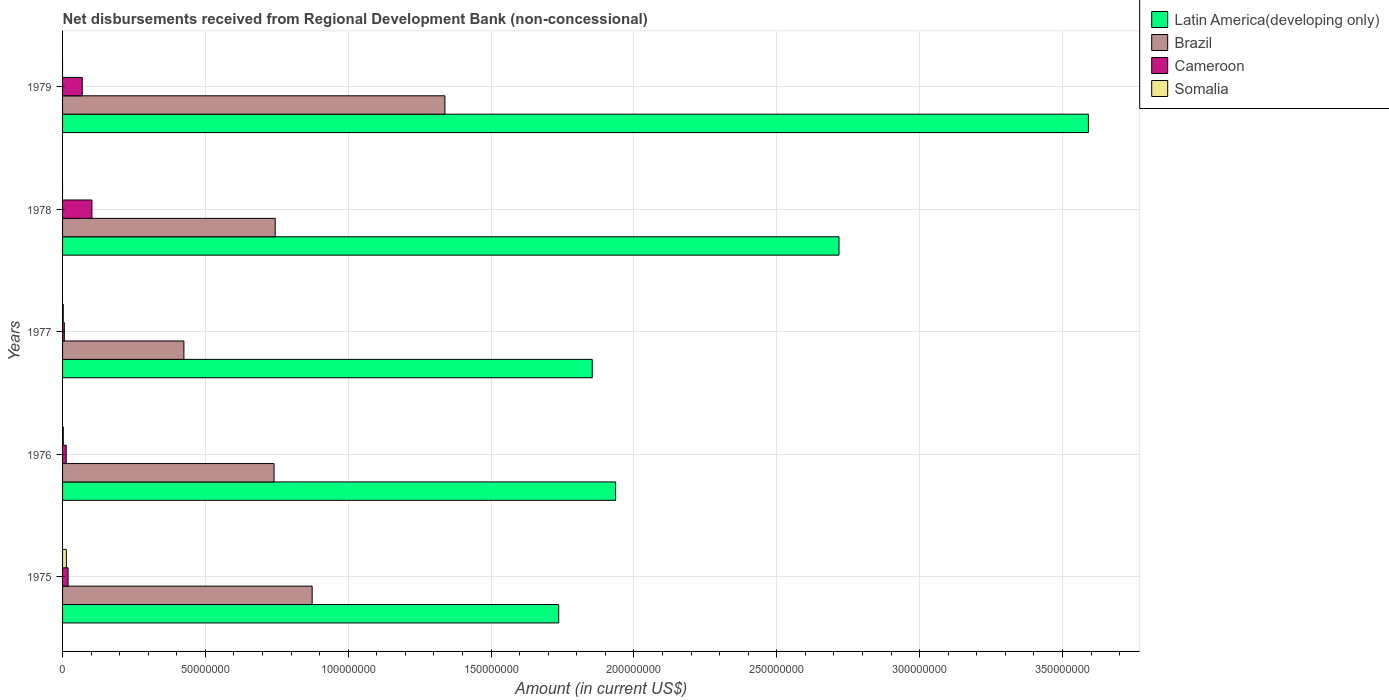Are the number of bars per tick equal to the number of legend labels?
Ensure brevity in your answer.  No. Are the number of bars on each tick of the Y-axis equal?
Your answer should be very brief. No. How many bars are there on the 2nd tick from the top?
Offer a very short reply. 3. What is the label of the 1st group of bars from the top?
Provide a short and direct response. 1979. What is the amount of disbursements received from Regional Development Bank in Brazil in 1978?
Ensure brevity in your answer.  7.44e+07. Across all years, what is the maximum amount of disbursements received from Regional Development Bank in Brazil?
Offer a very short reply. 1.34e+08. Across all years, what is the minimum amount of disbursements received from Regional Development Bank in Brazil?
Provide a short and direct response. 4.25e+07. In which year was the amount of disbursements received from Regional Development Bank in Brazil maximum?
Give a very brief answer. 1979. What is the total amount of disbursements received from Regional Development Bank in Latin America(developing only) in the graph?
Your response must be concise. 1.18e+09. What is the difference between the amount of disbursements received from Regional Development Bank in Brazil in 1975 and that in 1979?
Your response must be concise. -4.65e+07. What is the difference between the amount of disbursements received from Regional Development Bank in Brazil in 1978 and the amount of disbursements received from Regional Development Bank in Somalia in 1975?
Give a very brief answer. 7.31e+07. What is the average amount of disbursements received from Regional Development Bank in Brazil per year?
Offer a terse response. 8.24e+07. In the year 1978, what is the difference between the amount of disbursements received from Regional Development Bank in Latin America(developing only) and amount of disbursements received from Regional Development Bank in Brazil?
Your response must be concise. 1.97e+08. In how many years, is the amount of disbursements received from Regional Development Bank in Cameroon greater than 250000000 US$?
Offer a terse response. 0. What is the ratio of the amount of disbursements received from Regional Development Bank in Cameroon in 1977 to that in 1978?
Offer a terse response. 0.06. What is the difference between the highest and the second highest amount of disbursements received from Regional Development Bank in Somalia?
Give a very brief answer. 1.07e+06. What is the difference between the highest and the lowest amount of disbursements received from Regional Development Bank in Cameroon?
Keep it short and to the point. 9.65e+06. In how many years, is the amount of disbursements received from Regional Development Bank in Cameroon greater than the average amount of disbursements received from Regional Development Bank in Cameroon taken over all years?
Make the answer very short. 2. Is the sum of the amount of disbursements received from Regional Development Bank in Cameroon in 1975 and 1978 greater than the maximum amount of disbursements received from Regional Development Bank in Somalia across all years?
Provide a succinct answer. Yes. Is it the case that in every year, the sum of the amount of disbursements received from Regional Development Bank in Somalia and amount of disbursements received from Regional Development Bank in Cameroon is greater than the sum of amount of disbursements received from Regional Development Bank in Brazil and amount of disbursements received from Regional Development Bank in Latin America(developing only)?
Give a very brief answer. No. What is the difference between two consecutive major ticks on the X-axis?
Give a very brief answer. 5.00e+07. Does the graph contain grids?
Provide a short and direct response. Yes. What is the title of the graph?
Offer a terse response. Net disbursements received from Regional Development Bank (non-concessional). What is the label or title of the X-axis?
Keep it short and to the point. Amount (in current US$). What is the label or title of the Y-axis?
Your answer should be compact. Years. What is the Amount (in current US$) of Latin America(developing only) in 1975?
Keep it short and to the point. 1.74e+08. What is the Amount (in current US$) in Brazil in 1975?
Give a very brief answer. 8.74e+07. What is the Amount (in current US$) in Cameroon in 1975?
Offer a very short reply. 1.93e+06. What is the Amount (in current US$) in Somalia in 1975?
Your answer should be very brief. 1.33e+06. What is the Amount (in current US$) in Latin America(developing only) in 1976?
Provide a short and direct response. 1.94e+08. What is the Amount (in current US$) of Brazil in 1976?
Offer a terse response. 7.40e+07. What is the Amount (in current US$) in Cameroon in 1976?
Your response must be concise. 1.27e+06. What is the Amount (in current US$) in Somalia in 1976?
Offer a very short reply. 2.63e+05. What is the Amount (in current US$) of Latin America(developing only) in 1977?
Offer a very short reply. 1.85e+08. What is the Amount (in current US$) in Brazil in 1977?
Your response must be concise. 4.25e+07. What is the Amount (in current US$) of Cameroon in 1977?
Keep it short and to the point. 6.15e+05. What is the Amount (in current US$) in Somalia in 1977?
Provide a succinct answer. 2.51e+05. What is the Amount (in current US$) in Latin America(developing only) in 1978?
Your answer should be very brief. 2.72e+08. What is the Amount (in current US$) in Brazil in 1978?
Give a very brief answer. 7.44e+07. What is the Amount (in current US$) of Cameroon in 1978?
Keep it short and to the point. 1.03e+07. What is the Amount (in current US$) of Somalia in 1978?
Your response must be concise. 0. What is the Amount (in current US$) of Latin America(developing only) in 1979?
Provide a succinct answer. 3.59e+08. What is the Amount (in current US$) in Brazil in 1979?
Your answer should be compact. 1.34e+08. What is the Amount (in current US$) in Cameroon in 1979?
Make the answer very short. 6.90e+06. What is the Amount (in current US$) in Somalia in 1979?
Provide a short and direct response. 0. Across all years, what is the maximum Amount (in current US$) in Latin America(developing only)?
Give a very brief answer. 3.59e+08. Across all years, what is the maximum Amount (in current US$) in Brazil?
Provide a succinct answer. 1.34e+08. Across all years, what is the maximum Amount (in current US$) in Cameroon?
Your answer should be very brief. 1.03e+07. Across all years, what is the maximum Amount (in current US$) of Somalia?
Give a very brief answer. 1.33e+06. Across all years, what is the minimum Amount (in current US$) in Latin America(developing only)?
Your answer should be very brief. 1.74e+08. Across all years, what is the minimum Amount (in current US$) of Brazil?
Give a very brief answer. 4.25e+07. Across all years, what is the minimum Amount (in current US$) in Cameroon?
Your answer should be very brief. 6.15e+05. What is the total Amount (in current US$) in Latin America(developing only) in the graph?
Ensure brevity in your answer.  1.18e+09. What is the total Amount (in current US$) of Brazil in the graph?
Offer a terse response. 4.12e+08. What is the total Amount (in current US$) of Cameroon in the graph?
Your answer should be very brief. 2.10e+07. What is the total Amount (in current US$) of Somalia in the graph?
Offer a very short reply. 1.85e+06. What is the difference between the Amount (in current US$) of Latin America(developing only) in 1975 and that in 1976?
Offer a terse response. -1.99e+07. What is the difference between the Amount (in current US$) of Brazil in 1975 and that in 1976?
Your response must be concise. 1.33e+07. What is the difference between the Amount (in current US$) in Cameroon in 1975 and that in 1976?
Provide a short and direct response. 6.55e+05. What is the difference between the Amount (in current US$) of Somalia in 1975 and that in 1976?
Offer a very short reply. 1.07e+06. What is the difference between the Amount (in current US$) in Latin America(developing only) in 1975 and that in 1977?
Offer a terse response. -1.17e+07. What is the difference between the Amount (in current US$) of Brazil in 1975 and that in 1977?
Provide a short and direct response. 4.49e+07. What is the difference between the Amount (in current US$) in Cameroon in 1975 and that in 1977?
Provide a succinct answer. 1.31e+06. What is the difference between the Amount (in current US$) in Somalia in 1975 and that in 1977?
Offer a very short reply. 1.08e+06. What is the difference between the Amount (in current US$) in Latin America(developing only) in 1975 and that in 1978?
Your answer should be very brief. -9.81e+07. What is the difference between the Amount (in current US$) of Brazil in 1975 and that in 1978?
Your answer should be compact. 1.29e+07. What is the difference between the Amount (in current US$) of Cameroon in 1975 and that in 1978?
Provide a short and direct response. -8.34e+06. What is the difference between the Amount (in current US$) of Latin America(developing only) in 1975 and that in 1979?
Offer a terse response. -1.85e+08. What is the difference between the Amount (in current US$) of Brazil in 1975 and that in 1979?
Provide a short and direct response. -4.65e+07. What is the difference between the Amount (in current US$) in Cameroon in 1975 and that in 1979?
Offer a terse response. -4.97e+06. What is the difference between the Amount (in current US$) of Latin America(developing only) in 1976 and that in 1977?
Provide a short and direct response. 8.18e+06. What is the difference between the Amount (in current US$) of Brazil in 1976 and that in 1977?
Ensure brevity in your answer.  3.16e+07. What is the difference between the Amount (in current US$) of Cameroon in 1976 and that in 1977?
Offer a terse response. 6.56e+05. What is the difference between the Amount (in current US$) of Somalia in 1976 and that in 1977?
Make the answer very short. 1.20e+04. What is the difference between the Amount (in current US$) of Latin America(developing only) in 1976 and that in 1978?
Offer a terse response. -7.82e+07. What is the difference between the Amount (in current US$) of Brazil in 1976 and that in 1978?
Offer a terse response. -3.96e+05. What is the difference between the Amount (in current US$) in Cameroon in 1976 and that in 1978?
Your answer should be very brief. -9.00e+06. What is the difference between the Amount (in current US$) in Latin America(developing only) in 1976 and that in 1979?
Offer a very short reply. -1.65e+08. What is the difference between the Amount (in current US$) of Brazil in 1976 and that in 1979?
Offer a terse response. -5.98e+07. What is the difference between the Amount (in current US$) of Cameroon in 1976 and that in 1979?
Offer a very short reply. -5.62e+06. What is the difference between the Amount (in current US$) in Latin America(developing only) in 1977 and that in 1978?
Give a very brief answer. -8.64e+07. What is the difference between the Amount (in current US$) of Brazil in 1977 and that in 1978?
Keep it short and to the point. -3.20e+07. What is the difference between the Amount (in current US$) of Cameroon in 1977 and that in 1978?
Provide a succinct answer. -9.65e+06. What is the difference between the Amount (in current US$) of Latin America(developing only) in 1977 and that in 1979?
Keep it short and to the point. -1.74e+08. What is the difference between the Amount (in current US$) in Brazil in 1977 and that in 1979?
Make the answer very short. -9.14e+07. What is the difference between the Amount (in current US$) of Cameroon in 1977 and that in 1979?
Ensure brevity in your answer.  -6.28e+06. What is the difference between the Amount (in current US$) in Latin America(developing only) in 1978 and that in 1979?
Provide a succinct answer. -8.73e+07. What is the difference between the Amount (in current US$) in Brazil in 1978 and that in 1979?
Ensure brevity in your answer.  -5.94e+07. What is the difference between the Amount (in current US$) in Cameroon in 1978 and that in 1979?
Your response must be concise. 3.37e+06. What is the difference between the Amount (in current US$) of Latin America(developing only) in 1975 and the Amount (in current US$) of Brazil in 1976?
Offer a terse response. 9.96e+07. What is the difference between the Amount (in current US$) of Latin America(developing only) in 1975 and the Amount (in current US$) of Cameroon in 1976?
Your response must be concise. 1.72e+08. What is the difference between the Amount (in current US$) of Latin America(developing only) in 1975 and the Amount (in current US$) of Somalia in 1976?
Offer a very short reply. 1.73e+08. What is the difference between the Amount (in current US$) of Brazil in 1975 and the Amount (in current US$) of Cameroon in 1976?
Keep it short and to the point. 8.61e+07. What is the difference between the Amount (in current US$) in Brazil in 1975 and the Amount (in current US$) in Somalia in 1976?
Make the answer very short. 8.71e+07. What is the difference between the Amount (in current US$) of Cameroon in 1975 and the Amount (in current US$) of Somalia in 1976?
Offer a terse response. 1.66e+06. What is the difference between the Amount (in current US$) of Latin America(developing only) in 1975 and the Amount (in current US$) of Brazil in 1977?
Give a very brief answer. 1.31e+08. What is the difference between the Amount (in current US$) of Latin America(developing only) in 1975 and the Amount (in current US$) of Cameroon in 1977?
Keep it short and to the point. 1.73e+08. What is the difference between the Amount (in current US$) of Latin America(developing only) in 1975 and the Amount (in current US$) of Somalia in 1977?
Ensure brevity in your answer.  1.73e+08. What is the difference between the Amount (in current US$) in Brazil in 1975 and the Amount (in current US$) in Cameroon in 1977?
Offer a terse response. 8.67e+07. What is the difference between the Amount (in current US$) in Brazil in 1975 and the Amount (in current US$) in Somalia in 1977?
Provide a succinct answer. 8.71e+07. What is the difference between the Amount (in current US$) of Cameroon in 1975 and the Amount (in current US$) of Somalia in 1977?
Give a very brief answer. 1.68e+06. What is the difference between the Amount (in current US$) of Latin America(developing only) in 1975 and the Amount (in current US$) of Brazil in 1978?
Offer a terse response. 9.92e+07. What is the difference between the Amount (in current US$) in Latin America(developing only) in 1975 and the Amount (in current US$) in Cameroon in 1978?
Make the answer very short. 1.63e+08. What is the difference between the Amount (in current US$) of Brazil in 1975 and the Amount (in current US$) of Cameroon in 1978?
Provide a succinct answer. 7.71e+07. What is the difference between the Amount (in current US$) of Latin America(developing only) in 1975 and the Amount (in current US$) of Brazil in 1979?
Offer a terse response. 3.98e+07. What is the difference between the Amount (in current US$) of Latin America(developing only) in 1975 and the Amount (in current US$) of Cameroon in 1979?
Offer a very short reply. 1.67e+08. What is the difference between the Amount (in current US$) of Brazil in 1975 and the Amount (in current US$) of Cameroon in 1979?
Keep it short and to the point. 8.05e+07. What is the difference between the Amount (in current US$) of Latin America(developing only) in 1976 and the Amount (in current US$) of Brazil in 1977?
Your answer should be very brief. 1.51e+08. What is the difference between the Amount (in current US$) of Latin America(developing only) in 1976 and the Amount (in current US$) of Cameroon in 1977?
Offer a terse response. 1.93e+08. What is the difference between the Amount (in current US$) of Latin America(developing only) in 1976 and the Amount (in current US$) of Somalia in 1977?
Provide a succinct answer. 1.93e+08. What is the difference between the Amount (in current US$) of Brazil in 1976 and the Amount (in current US$) of Cameroon in 1977?
Ensure brevity in your answer.  7.34e+07. What is the difference between the Amount (in current US$) in Brazil in 1976 and the Amount (in current US$) in Somalia in 1977?
Your response must be concise. 7.38e+07. What is the difference between the Amount (in current US$) in Cameroon in 1976 and the Amount (in current US$) in Somalia in 1977?
Offer a very short reply. 1.02e+06. What is the difference between the Amount (in current US$) in Latin America(developing only) in 1976 and the Amount (in current US$) in Brazil in 1978?
Your answer should be very brief. 1.19e+08. What is the difference between the Amount (in current US$) of Latin America(developing only) in 1976 and the Amount (in current US$) of Cameroon in 1978?
Your answer should be compact. 1.83e+08. What is the difference between the Amount (in current US$) in Brazil in 1976 and the Amount (in current US$) in Cameroon in 1978?
Give a very brief answer. 6.38e+07. What is the difference between the Amount (in current US$) of Latin America(developing only) in 1976 and the Amount (in current US$) of Brazil in 1979?
Make the answer very short. 5.98e+07. What is the difference between the Amount (in current US$) of Latin America(developing only) in 1976 and the Amount (in current US$) of Cameroon in 1979?
Offer a terse response. 1.87e+08. What is the difference between the Amount (in current US$) in Brazil in 1976 and the Amount (in current US$) in Cameroon in 1979?
Give a very brief answer. 6.71e+07. What is the difference between the Amount (in current US$) in Latin America(developing only) in 1977 and the Amount (in current US$) in Brazil in 1978?
Your answer should be very brief. 1.11e+08. What is the difference between the Amount (in current US$) in Latin America(developing only) in 1977 and the Amount (in current US$) in Cameroon in 1978?
Provide a short and direct response. 1.75e+08. What is the difference between the Amount (in current US$) in Brazil in 1977 and the Amount (in current US$) in Cameroon in 1978?
Your answer should be compact. 3.22e+07. What is the difference between the Amount (in current US$) of Latin America(developing only) in 1977 and the Amount (in current US$) of Brazil in 1979?
Provide a succinct answer. 5.16e+07. What is the difference between the Amount (in current US$) in Latin America(developing only) in 1977 and the Amount (in current US$) in Cameroon in 1979?
Your answer should be very brief. 1.79e+08. What is the difference between the Amount (in current US$) in Brazil in 1977 and the Amount (in current US$) in Cameroon in 1979?
Provide a succinct answer. 3.56e+07. What is the difference between the Amount (in current US$) in Latin America(developing only) in 1978 and the Amount (in current US$) in Brazil in 1979?
Provide a succinct answer. 1.38e+08. What is the difference between the Amount (in current US$) in Latin America(developing only) in 1978 and the Amount (in current US$) in Cameroon in 1979?
Offer a very short reply. 2.65e+08. What is the difference between the Amount (in current US$) of Brazil in 1978 and the Amount (in current US$) of Cameroon in 1979?
Keep it short and to the point. 6.75e+07. What is the average Amount (in current US$) of Latin America(developing only) per year?
Provide a succinct answer. 2.37e+08. What is the average Amount (in current US$) in Brazil per year?
Keep it short and to the point. 8.24e+07. What is the average Amount (in current US$) in Cameroon per year?
Offer a very short reply. 4.20e+06. What is the average Amount (in current US$) of Somalia per year?
Offer a terse response. 3.69e+05. In the year 1975, what is the difference between the Amount (in current US$) of Latin America(developing only) and Amount (in current US$) of Brazil?
Provide a succinct answer. 8.63e+07. In the year 1975, what is the difference between the Amount (in current US$) in Latin America(developing only) and Amount (in current US$) in Cameroon?
Your answer should be compact. 1.72e+08. In the year 1975, what is the difference between the Amount (in current US$) of Latin America(developing only) and Amount (in current US$) of Somalia?
Keep it short and to the point. 1.72e+08. In the year 1975, what is the difference between the Amount (in current US$) of Brazil and Amount (in current US$) of Cameroon?
Ensure brevity in your answer.  8.54e+07. In the year 1975, what is the difference between the Amount (in current US$) of Brazil and Amount (in current US$) of Somalia?
Offer a very short reply. 8.60e+07. In the year 1975, what is the difference between the Amount (in current US$) of Cameroon and Amount (in current US$) of Somalia?
Your answer should be compact. 5.93e+05. In the year 1976, what is the difference between the Amount (in current US$) in Latin America(developing only) and Amount (in current US$) in Brazil?
Your response must be concise. 1.20e+08. In the year 1976, what is the difference between the Amount (in current US$) of Latin America(developing only) and Amount (in current US$) of Cameroon?
Offer a terse response. 1.92e+08. In the year 1976, what is the difference between the Amount (in current US$) of Latin America(developing only) and Amount (in current US$) of Somalia?
Provide a succinct answer. 1.93e+08. In the year 1976, what is the difference between the Amount (in current US$) in Brazil and Amount (in current US$) in Cameroon?
Keep it short and to the point. 7.28e+07. In the year 1976, what is the difference between the Amount (in current US$) of Brazil and Amount (in current US$) of Somalia?
Keep it short and to the point. 7.38e+07. In the year 1976, what is the difference between the Amount (in current US$) of Cameroon and Amount (in current US$) of Somalia?
Provide a succinct answer. 1.01e+06. In the year 1977, what is the difference between the Amount (in current US$) of Latin America(developing only) and Amount (in current US$) of Brazil?
Offer a terse response. 1.43e+08. In the year 1977, what is the difference between the Amount (in current US$) in Latin America(developing only) and Amount (in current US$) in Cameroon?
Ensure brevity in your answer.  1.85e+08. In the year 1977, what is the difference between the Amount (in current US$) in Latin America(developing only) and Amount (in current US$) in Somalia?
Provide a short and direct response. 1.85e+08. In the year 1977, what is the difference between the Amount (in current US$) of Brazil and Amount (in current US$) of Cameroon?
Offer a very short reply. 4.19e+07. In the year 1977, what is the difference between the Amount (in current US$) of Brazil and Amount (in current US$) of Somalia?
Offer a terse response. 4.22e+07. In the year 1977, what is the difference between the Amount (in current US$) in Cameroon and Amount (in current US$) in Somalia?
Your answer should be compact. 3.64e+05. In the year 1978, what is the difference between the Amount (in current US$) in Latin America(developing only) and Amount (in current US$) in Brazil?
Give a very brief answer. 1.97e+08. In the year 1978, what is the difference between the Amount (in current US$) of Latin America(developing only) and Amount (in current US$) of Cameroon?
Offer a very short reply. 2.62e+08. In the year 1978, what is the difference between the Amount (in current US$) of Brazil and Amount (in current US$) of Cameroon?
Keep it short and to the point. 6.42e+07. In the year 1979, what is the difference between the Amount (in current US$) of Latin America(developing only) and Amount (in current US$) of Brazil?
Make the answer very short. 2.25e+08. In the year 1979, what is the difference between the Amount (in current US$) in Latin America(developing only) and Amount (in current US$) in Cameroon?
Provide a succinct answer. 3.52e+08. In the year 1979, what is the difference between the Amount (in current US$) of Brazil and Amount (in current US$) of Cameroon?
Offer a terse response. 1.27e+08. What is the ratio of the Amount (in current US$) in Latin America(developing only) in 1975 to that in 1976?
Give a very brief answer. 0.9. What is the ratio of the Amount (in current US$) in Brazil in 1975 to that in 1976?
Offer a terse response. 1.18. What is the ratio of the Amount (in current US$) in Cameroon in 1975 to that in 1976?
Make the answer very short. 1.52. What is the ratio of the Amount (in current US$) of Somalia in 1975 to that in 1976?
Keep it short and to the point. 5.07. What is the ratio of the Amount (in current US$) in Latin America(developing only) in 1975 to that in 1977?
Offer a very short reply. 0.94. What is the ratio of the Amount (in current US$) of Brazil in 1975 to that in 1977?
Your answer should be compact. 2.06. What is the ratio of the Amount (in current US$) of Cameroon in 1975 to that in 1977?
Your answer should be very brief. 3.13. What is the ratio of the Amount (in current US$) in Somalia in 1975 to that in 1977?
Your answer should be compact. 5.31. What is the ratio of the Amount (in current US$) in Latin America(developing only) in 1975 to that in 1978?
Provide a short and direct response. 0.64. What is the ratio of the Amount (in current US$) of Brazil in 1975 to that in 1978?
Provide a succinct answer. 1.17. What is the ratio of the Amount (in current US$) of Cameroon in 1975 to that in 1978?
Your response must be concise. 0.19. What is the ratio of the Amount (in current US$) in Latin America(developing only) in 1975 to that in 1979?
Your answer should be very brief. 0.48. What is the ratio of the Amount (in current US$) of Brazil in 1975 to that in 1979?
Make the answer very short. 0.65. What is the ratio of the Amount (in current US$) of Cameroon in 1975 to that in 1979?
Ensure brevity in your answer.  0.28. What is the ratio of the Amount (in current US$) of Latin America(developing only) in 1976 to that in 1977?
Make the answer very short. 1.04. What is the ratio of the Amount (in current US$) in Brazil in 1976 to that in 1977?
Offer a terse response. 1.74. What is the ratio of the Amount (in current US$) in Cameroon in 1976 to that in 1977?
Your answer should be very brief. 2.07. What is the ratio of the Amount (in current US$) of Somalia in 1976 to that in 1977?
Your answer should be compact. 1.05. What is the ratio of the Amount (in current US$) of Latin America(developing only) in 1976 to that in 1978?
Your answer should be very brief. 0.71. What is the ratio of the Amount (in current US$) in Cameroon in 1976 to that in 1978?
Your answer should be compact. 0.12. What is the ratio of the Amount (in current US$) in Latin America(developing only) in 1976 to that in 1979?
Your answer should be very brief. 0.54. What is the ratio of the Amount (in current US$) in Brazil in 1976 to that in 1979?
Give a very brief answer. 0.55. What is the ratio of the Amount (in current US$) of Cameroon in 1976 to that in 1979?
Make the answer very short. 0.18. What is the ratio of the Amount (in current US$) of Latin America(developing only) in 1977 to that in 1978?
Ensure brevity in your answer.  0.68. What is the ratio of the Amount (in current US$) of Brazil in 1977 to that in 1978?
Offer a terse response. 0.57. What is the ratio of the Amount (in current US$) of Cameroon in 1977 to that in 1978?
Offer a terse response. 0.06. What is the ratio of the Amount (in current US$) in Latin America(developing only) in 1977 to that in 1979?
Ensure brevity in your answer.  0.52. What is the ratio of the Amount (in current US$) of Brazil in 1977 to that in 1979?
Your response must be concise. 0.32. What is the ratio of the Amount (in current US$) in Cameroon in 1977 to that in 1979?
Give a very brief answer. 0.09. What is the ratio of the Amount (in current US$) in Latin America(developing only) in 1978 to that in 1979?
Make the answer very short. 0.76. What is the ratio of the Amount (in current US$) of Brazil in 1978 to that in 1979?
Your answer should be very brief. 0.56. What is the ratio of the Amount (in current US$) in Cameroon in 1978 to that in 1979?
Give a very brief answer. 1.49. What is the difference between the highest and the second highest Amount (in current US$) in Latin America(developing only)?
Give a very brief answer. 8.73e+07. What is the difference between the highest and the second highest Amount (in current US$) of Brazil?
Provide a short and direct response. 4.65e+07. What is the difference between the highest and the second highest Amount (in current US$) in Cameroon?
Offer a very short reply. 3.37e+06. What is the difference between the highest and the second highest Amount (in current US$) of Somalia?
Offer a very short reply. 1.07e+06. What is the difference between the highest and the lowest Amount (in current US$) in Latin America(developing only)?
Provide a short and direct response. 1.85e+08. What is the difference between the highest and the lowest Amount (in current US$) in Brazil?
Give a very brief answer. 9.14e+07. What is the difference between the highest and the lowest Amount (in current US$) of Cameroon?
Offer a very short reply. 9.65e+06. What is the difference between the highest and the lowest Amount (in current US$) of Somalia?
Provide a short and direct response. 1.33e+06. 